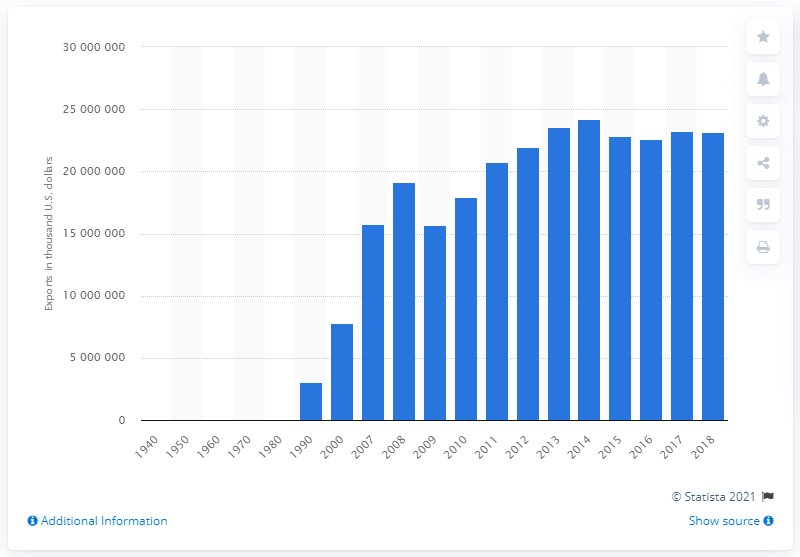Give some essential details in this illustration. The United States began exporting nonedible fishery products in 1940. 